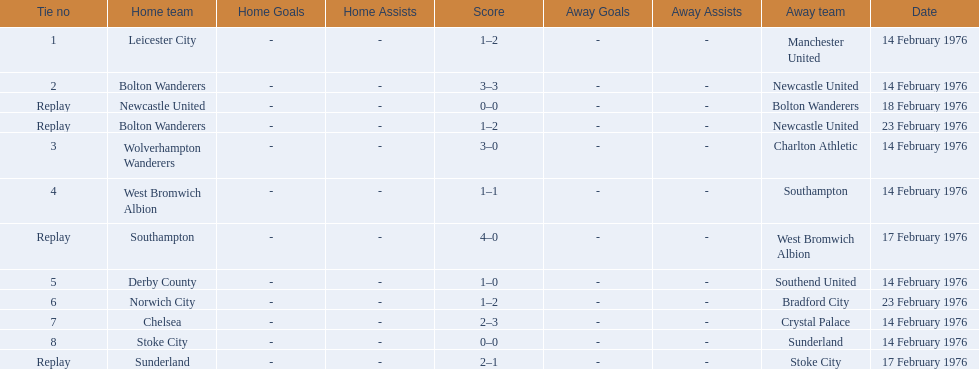Who were all of the teams? Leicester City, Manchester United, Bolton Wanderers, Newcastle United, Newcastle United, Bolton Wanderers, Bolton Wanderers, Newcastle United, Wolverhampton Wanderers, Charlton Athletic, West Bromwich Albion, Southampton, Southampton, West Bromwich Albion, Derby County, Southend United, Norwich City, Bradford City, Chelsea, Crystal Palace, Stoke City, Sunderland, Sunderland, Stoke City. Would you be able to parse every entry in this table? {'header': ['Tie no', 'Home team', 'Home Goals', 'Home Assists', 'Score', 'Away Goals', 'Away Assists', 'Away team', 'Date'], 'rows': [['1', 'Leicester City', '-', '-', '1–2', '-', '-', 'Manchester United', '14 February 1976'], ['2', 'Bolton Wanderers', '-', '-', '3–3', '-', '-', 'Newcastle United', '14 February 1976'], ['Replay', 'Newcastle United', '-', '-', '0–0', '-', '-', 'Bolton Wanderers', '18 February 1976'], ['Replay', 'Bolton Wanderers', '-', '-', '1–2', '-', '-', 'Newcastle United', '23 February 1976'], ['3', 'Wolverhampton Wanderers', '-', '-', '3–0', '-', '-', 'Charlton Athletic', '14 February 1976'], ['4', 'West Bromwich Albion', '-', '-', '1–1', '-', '-', 'Southampton', '14 February 1976'], ['Replay', 'Southampton', '-', '-', '4–0', '-', '-', 'West Bromwich Albion', '17 February 1976'], ['5', 'Derby County', '-', '-', '1–0', '-', '-', 'Southend United', '14 February 1976'], ['6', 'Norwich City', '-', '-', '1–2', '-', '-', 'Bradford City', '23 February 1976'], ['7', 'Chelsea', '-', '-', '2–3', '-', '-', 'Crystal Palace', '14 February 1976'], ['8', 'Stoke City', '-', '-', '0–0', '-', '-', 'Sunderland', '14 February 1976'], ['Replay', 'Sunderland', '-', '-', '2–1', '-', '-', 'Stoke City', '17 February 1976']]} And what were their scores? 1–2, 3–3, 0–0, 1–2, 3–0, 1–1, 4–0, 1–0, 1–2, 2–3, 0–0, 2–1. Between manchester and wolverhampton, who scored more? Wolverhampton Wanderers. 